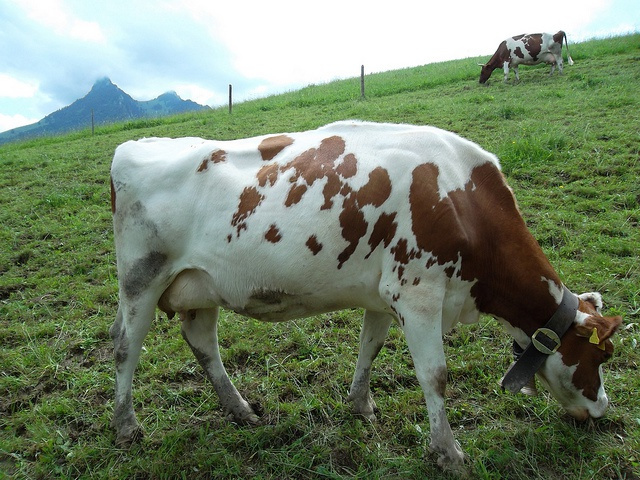Describe the objects in this image and their specific colors. I can see cow in lightblue, gray, black, darkgray, and lightgray tones and cow in lightblue, gray, black, and darkgray tones in this image. 